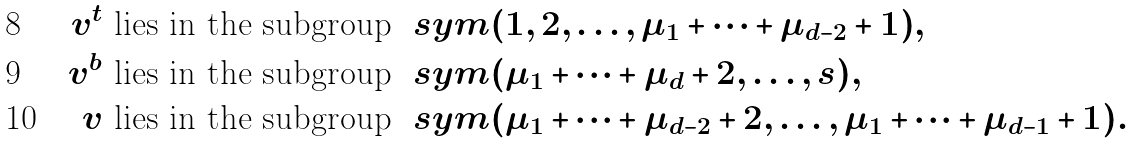<formula> <loc_0><loc_0><loc_500><loc_500>v ^ { t } & \text { lies in the subgroup } \ s y m { ( 1 , 2 , \dots , \mu _ { 1 } + \dots + \mu _ { d - 2 } + 1 ) } , \\ v ^ { b } & \text { lies in the subgroup } \ s y m { ( \mu _ { 1 } + \dots + \mu _ { d } + 2 , \dots , s ) } , \\ v & \text { lies in the subgroup } \ s y m { ( \mu _ { 1 } + \dots + \mu _ { d - 2 } + 2 , \dots , \mu _ { 1 } + \dots + \mu _ { d - 1 } + 1 ) } .</formula> 